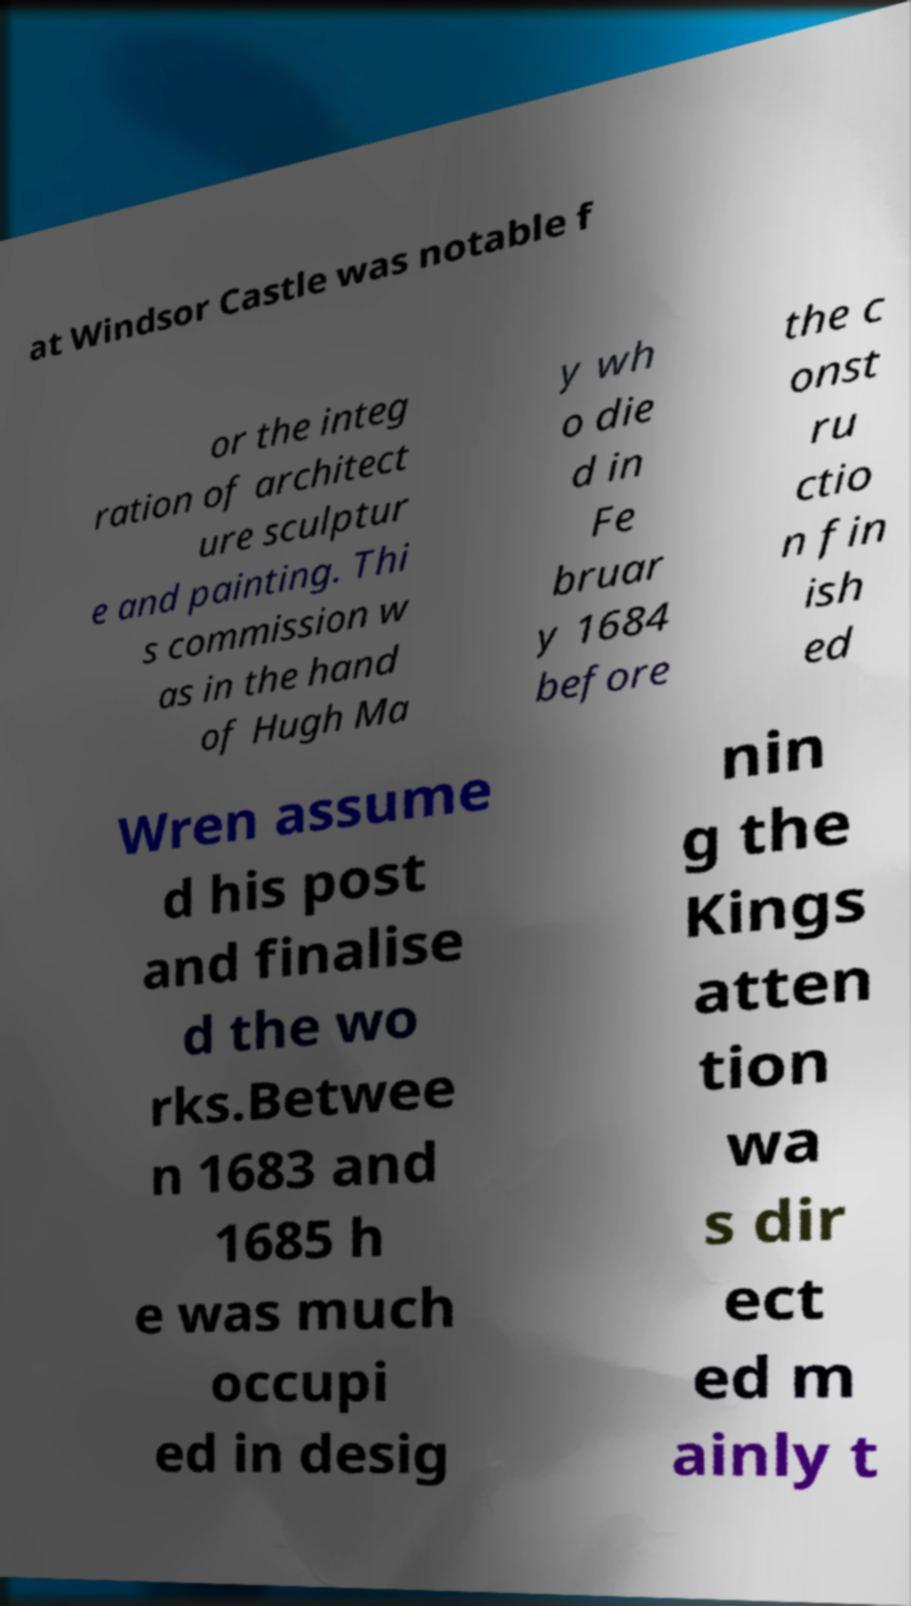Could you extract and type out the text from this image? at Windsor Castle was notable f or the integ ration of architect ure sculptur e and painting. Thi s commission w as in the hand of Hugh Ma y wh o die d in Fe bruar y 1684 before the c onst ru ctio n fin ish ed Wren assume d his post and finalise d the wo rks.Betwee n 1683 and 1685 h e was much occupi ed in desig nin g the Kings atten tion wa s dir ect ed m ainly t 